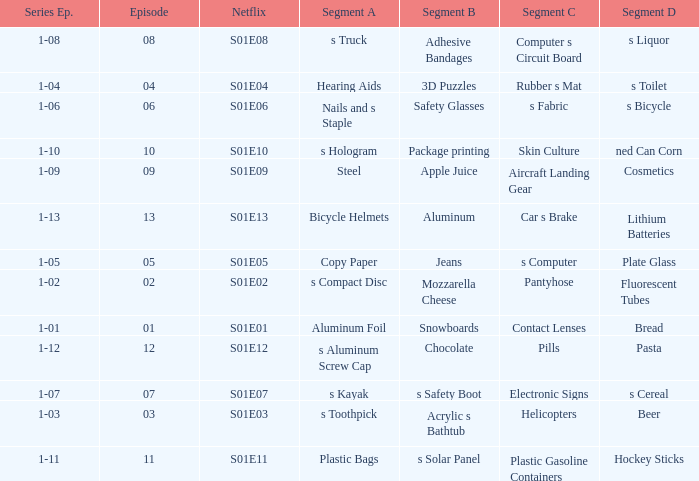What is the Netflix number having a segment D, of NED can corn? S01E10. 